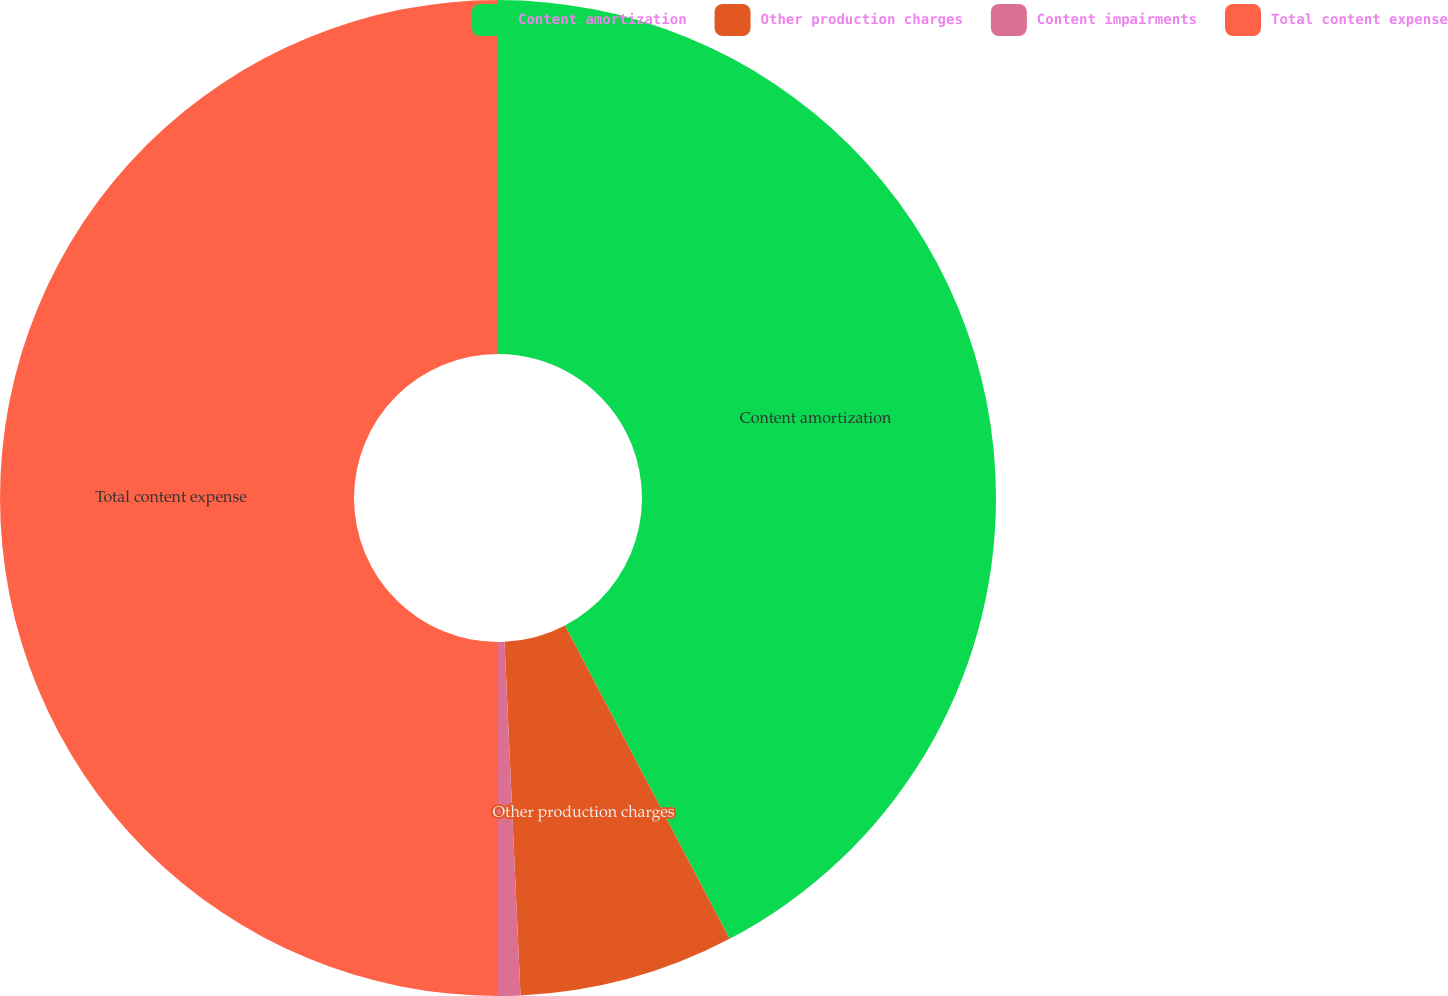Convert chart. <chart><loc_0><loc_0><loc_500><loc_500><pie_chart><fcel>Content amortization<fcel>Other production charges<fcel>Content impairments<fcel>Total content expense<nl><fcel>42.3%<fcel>6.98%<fcel>0.72%<fcel>50.0%<nl></chart> 